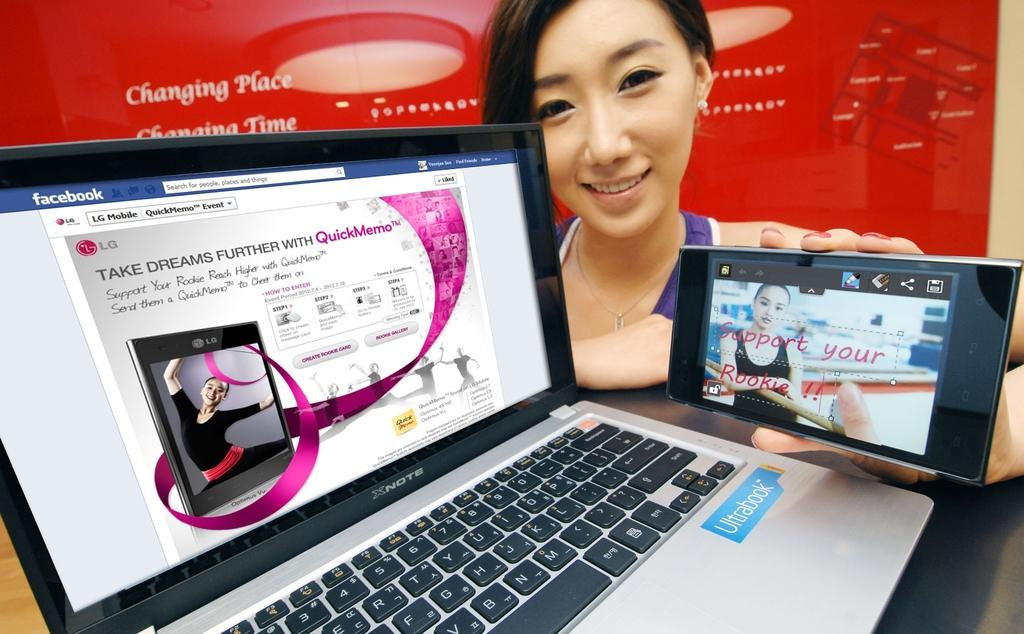<image>
Summarize the visual content of the image. A laptop has an Ultrabook logo below the keyboard. 